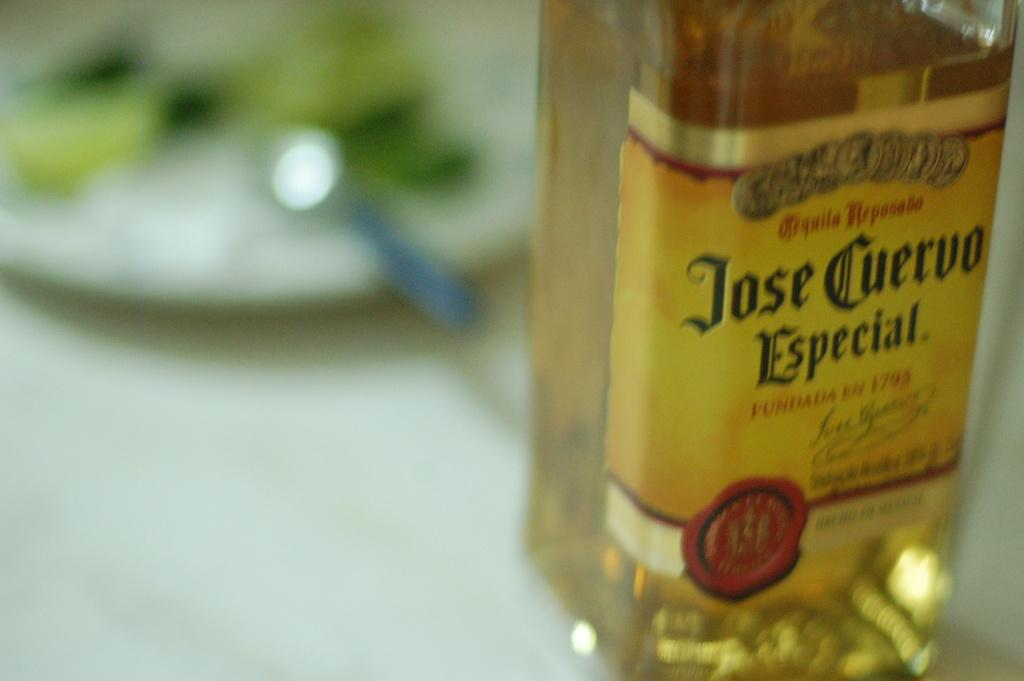Provide a one-sentence caption for the provided image. The Jose Cuervo tequila bottle sits next to plate with food on it. 